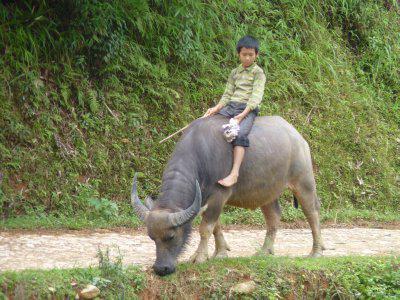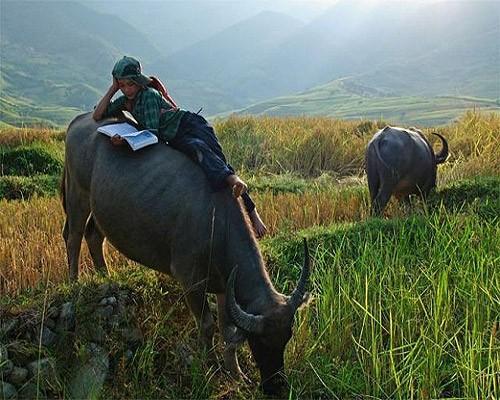The first image is the image on the left, the second image is the image on the right. For the images displayed, is the sentence "There is at least one person in each image with a water buffalo." factually correct? Answer yes or no. Yes. The first image is the image on the left, the second image is the image on the right. For the images shown, is this caption "Only one of the images contains a sole rider on a water buffalo." true? Answer yes or no. No. 